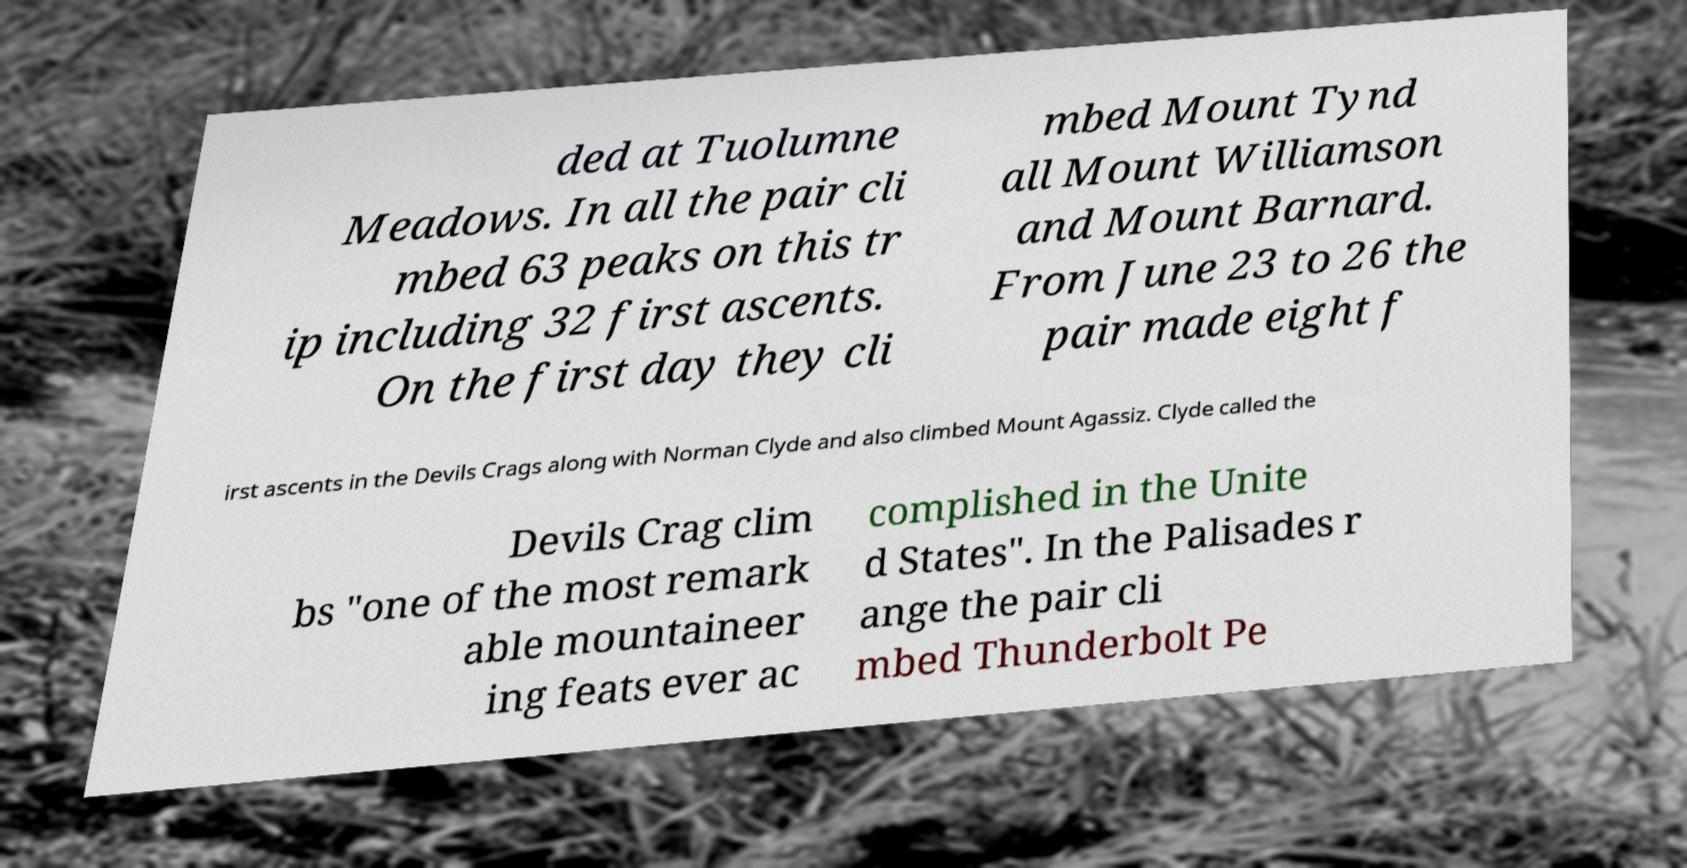Please identify and transcribe the text found in this image. ded at Tuolumne Meadows. In all the pair cli mbed 63 peaks on this tr ip including 32 first ascents. On the first day they cli mbed Mount Tynd all Mount Williamson and Mount Barnard. From June 23 to 26 the pair made eight f irst ascents in the Devils Crags along with Norman Clyde and also climbed Mount Agassiz. Clyde called the Devils Crag clim bs "one of the most remark able mountaineer ing feats ever ac complished in the Unite d States". In the Palisades r ange the pair cli mbed Thunderbolt Pe 